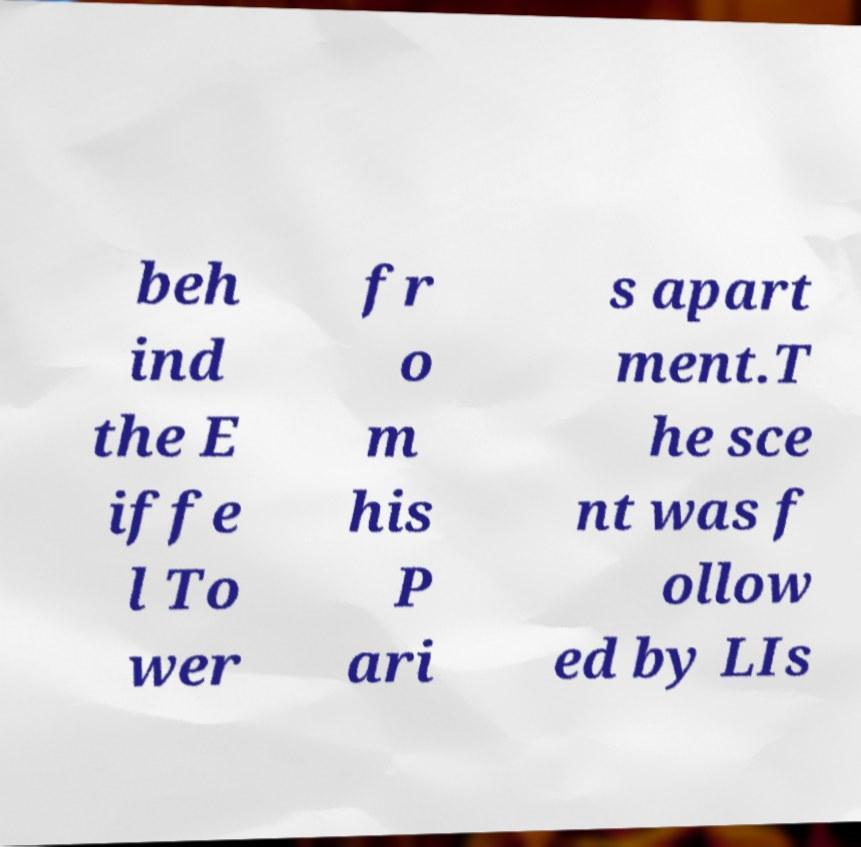There's text embedded in this image that I need extracted. Can you transcribe it verbatim? beh ind the E iffe l To wer fr o m his P ari s apart ment.T he sce nt was f ollow ed by LIs 